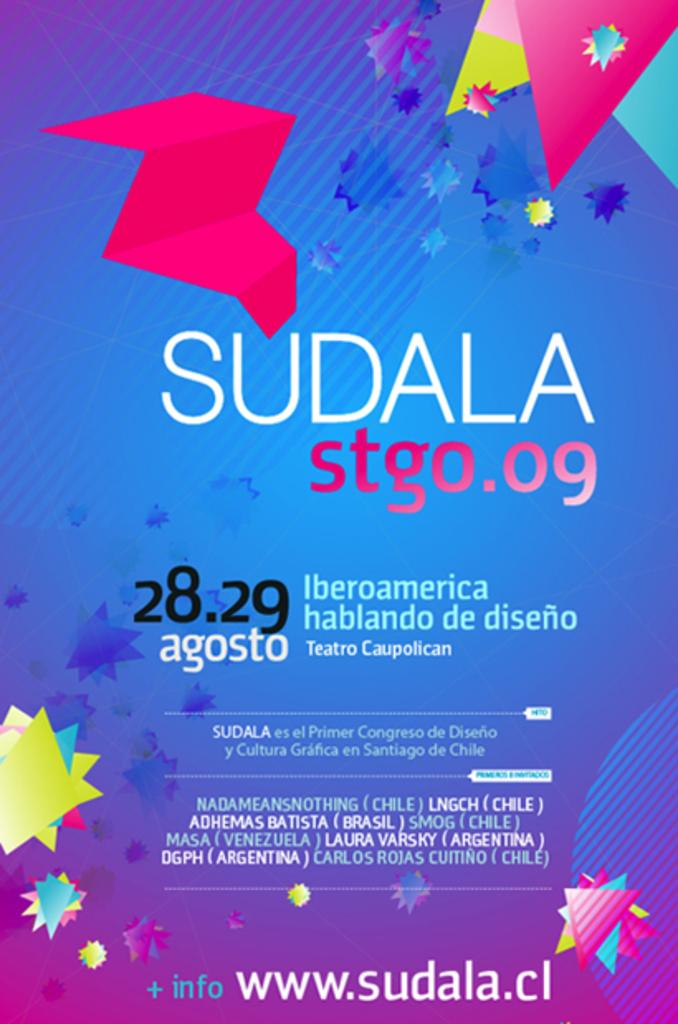<image>
Share a concise interpretation of the image provided. An advertisement for Sudala showing more info can be found at www.sudala.cl 